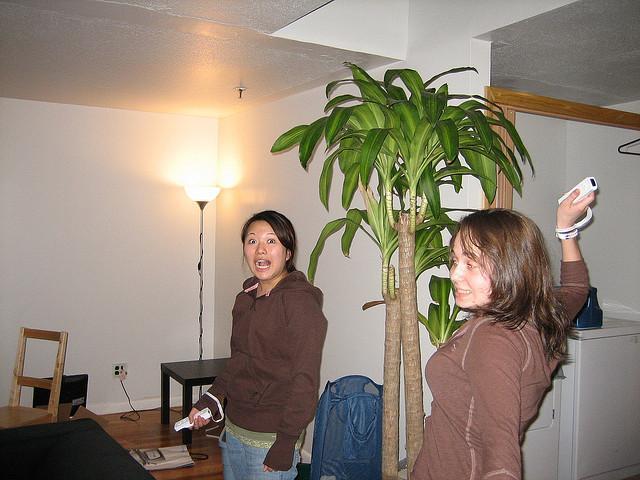How many light bulbs are here?
Give a very brief answer. 1. How many people are in the picture?
Give a very brief answer. 2. How many dining tables are there?
Give a very brief answer. 1. 